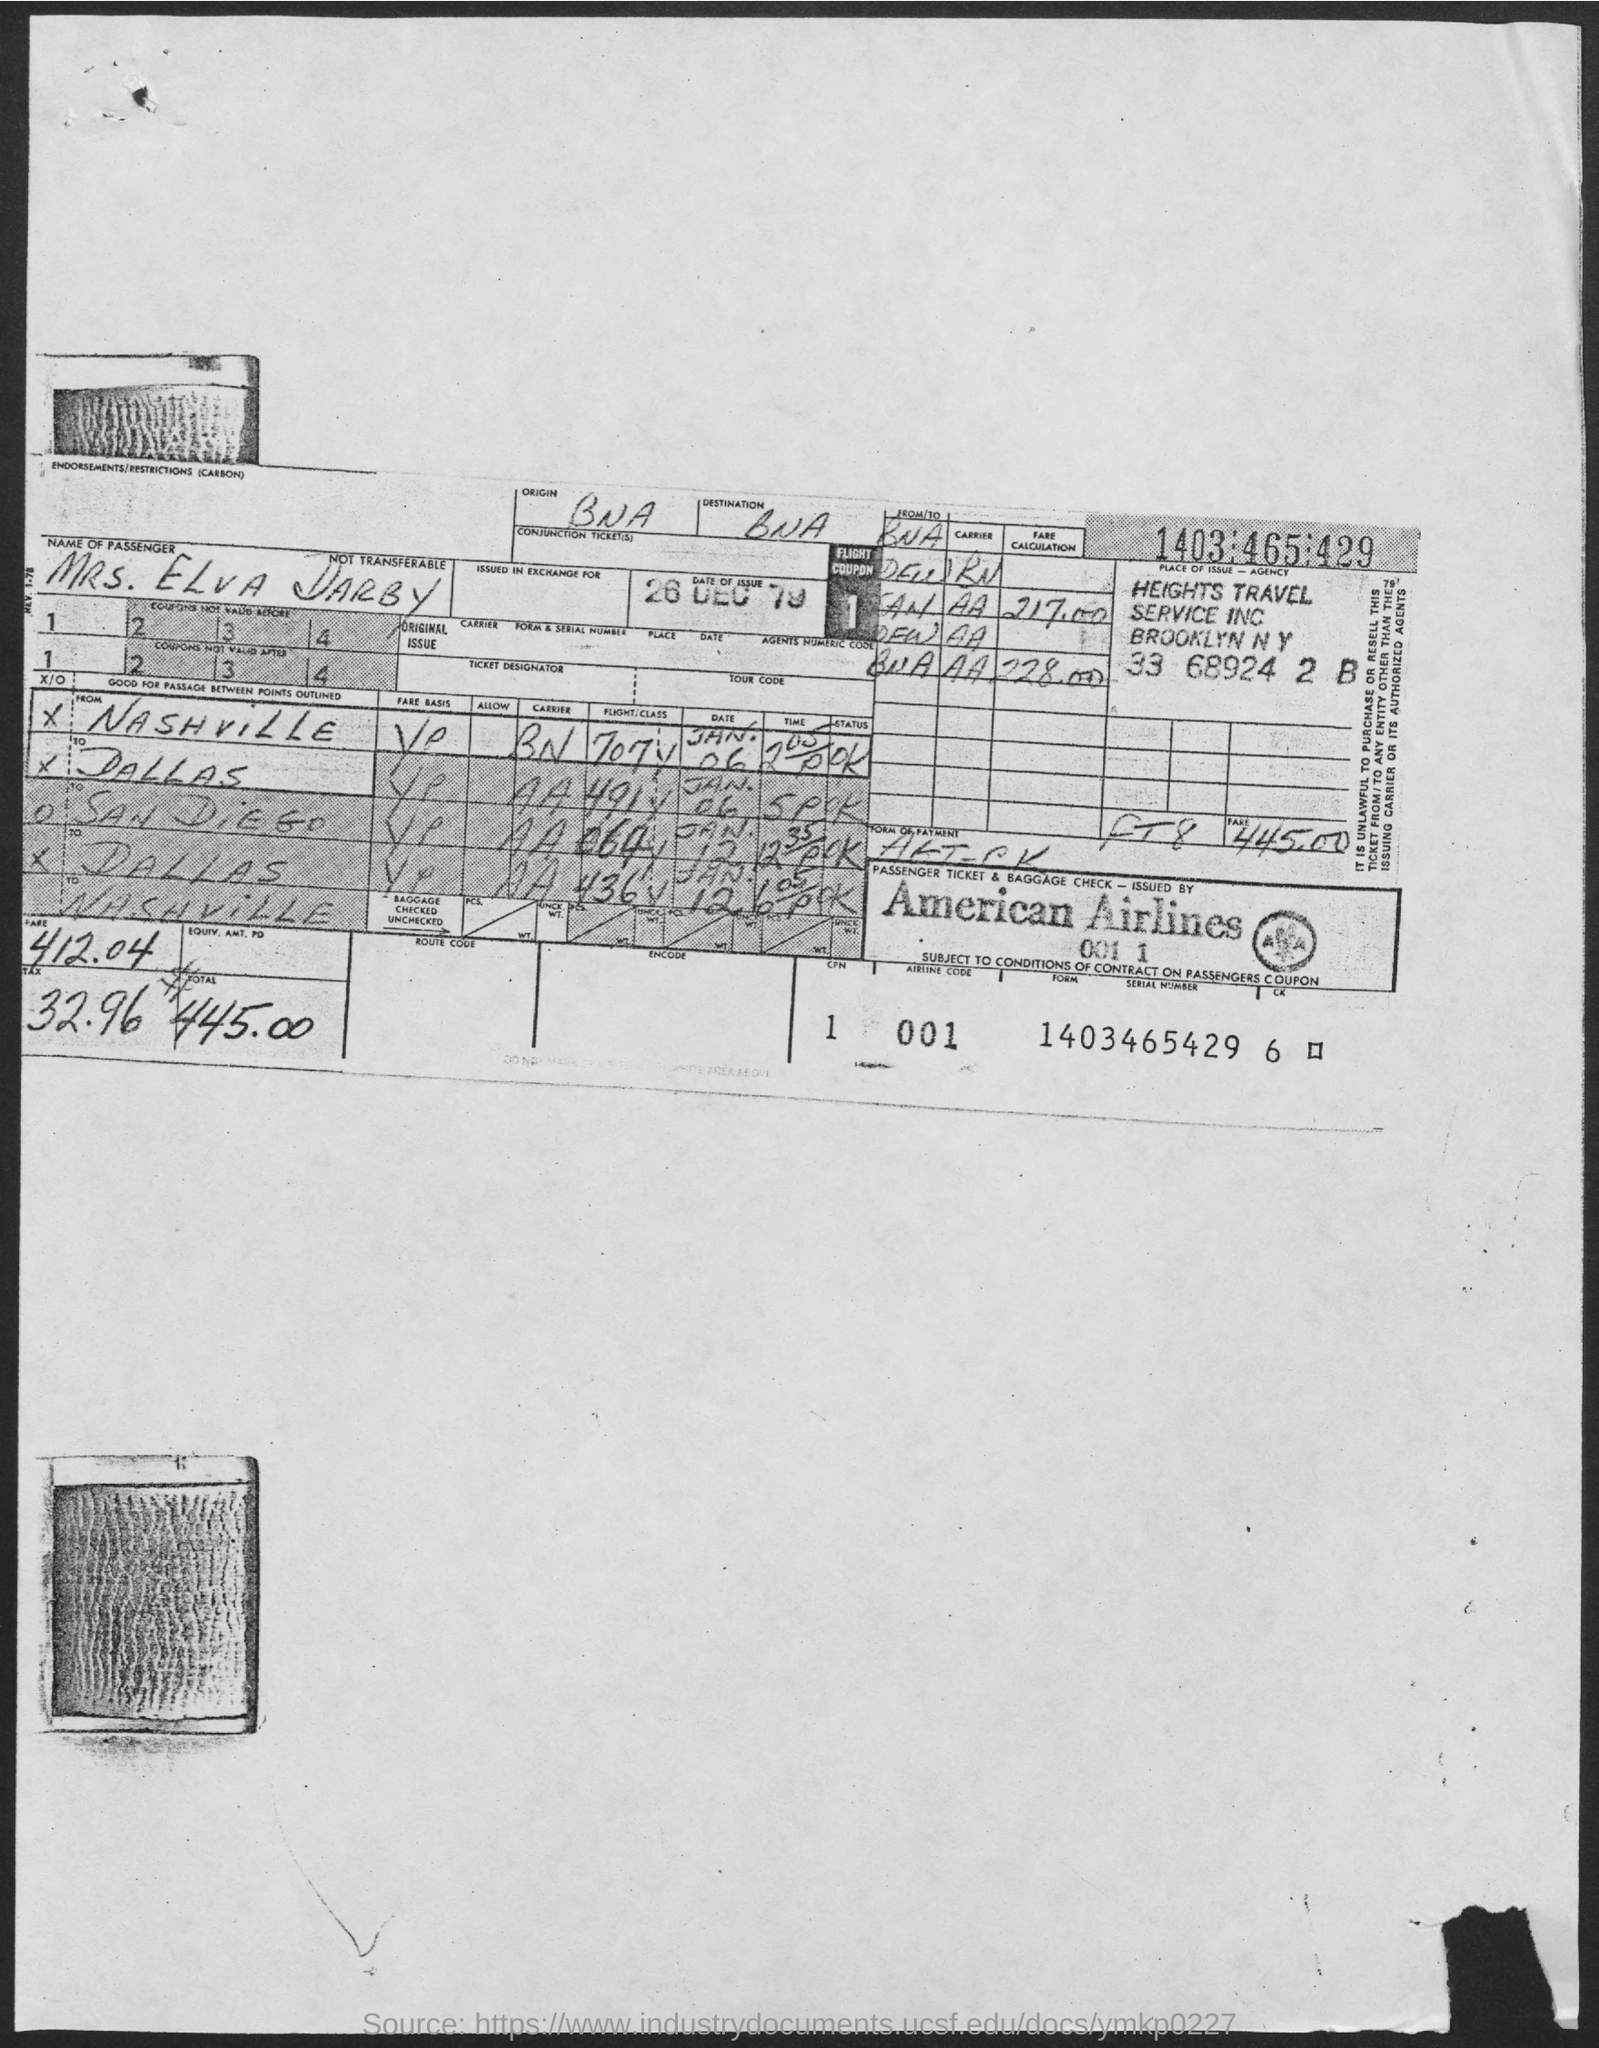Draw attention to some important aspects in this diagram. The airline code is 001. The name of the passenger is Mrs. Elva Darby. The date of issue is December 26, 1979. 